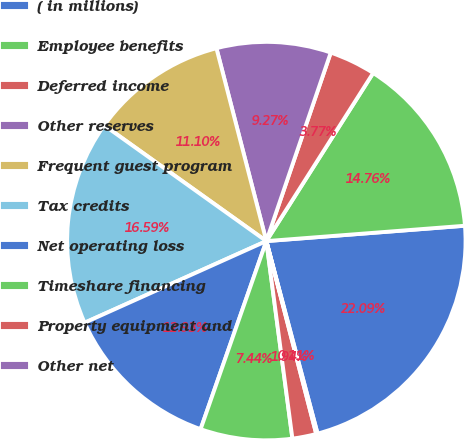<chart> <loc_0><loc_0><loc_500><loc_500><pie_chart><fcel>( in millions)<fcel>Employee benefits<fcel>Deferred income<fcel>Other reserves<fcel>Frequent guest program<fcel>Tax credits<fcel>Net operating loss<fcel>Timeshare financing<fcel>Property equipment and<fcel>Other net<nl><fcel>22.09%<fcel>14.76%<fcel>3.77%<fcel>9.27%<fcel>11.1%<fcel>16.59%<fcel>12.93%<fcel>7.44%<fcel>1.94%<fcel>0.11%<nl></chart> 